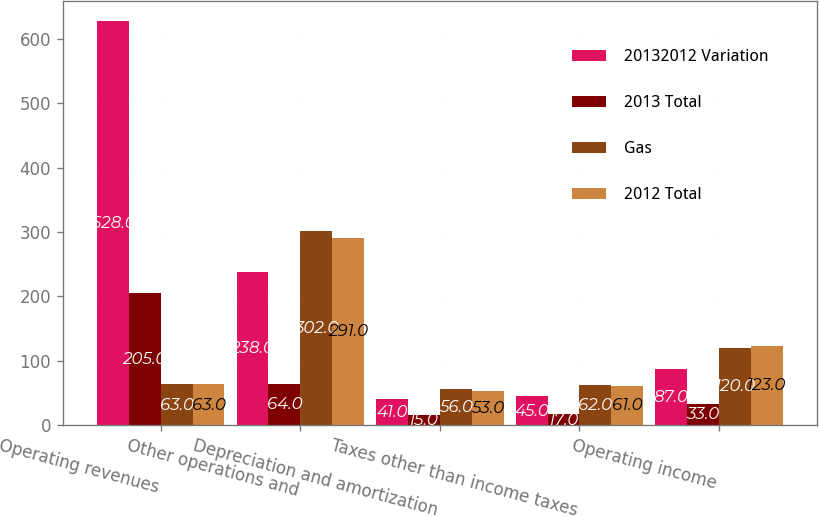<chart> <loc_0><loc_0><loc_500><loc_500><stacked_bar_chart><ecel><fcel>Operating revenues<fcel>Other operations and<fcel>Depreciation and amortization<fcel>Taxes other than income taxes<fcel>Operating income<nl><fcel>20132012 Variation<fcel>628<fcel>238<fcel>41<fcel>45<fcel>87<nl><fcel>2013 Total<fcel>205<fcel>64<fcel>15<fcel>17<fcel>33<nl><fcel>Gas<fcel>63<fcel>302<fcel>56<fcel>62<fcel>120<nl><fcel>2012 Total<fcel>63<fcel>291<fcel>53<fcel>61<fcel>123<nl></chart> 